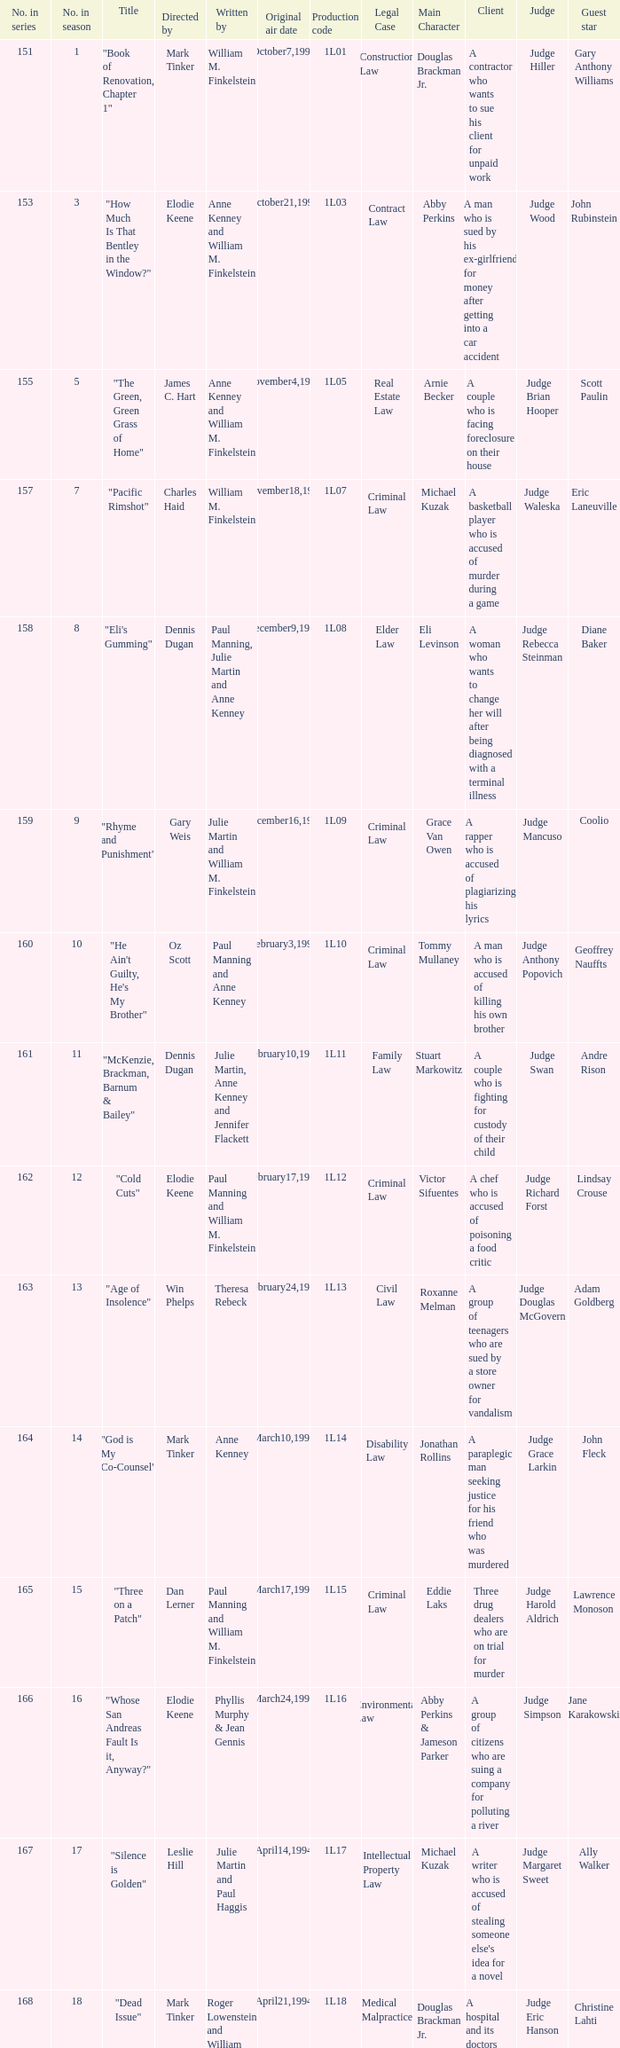Name who directed the production code 1l10 Oz Scott. 